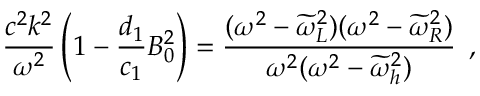Convert formula to latex. <formula><loc_0><loc_0><loc_500><loc_500>\frac { c ^ { 2 } k ^ { 2 } } { \omega ^ { 2 } } \left ( 1 - \frac { d _ { 1 } } { c _ { 1 } } B _ { 0 } ^ { 2 } \right ) = \frac { ( \omega ^ { 2 } - \widetilde { \omega } _ { L } ^ { 2 } ) ( \omega ^ { 2 } - \widetilde { \omega } _ { R } ^ { 2 } ) } { \omega ^ { 2 } ( \omega ^ { 2 } - \widetilde { \omega } _ { h } ^ { 2 } ) } \, ,</formula> 